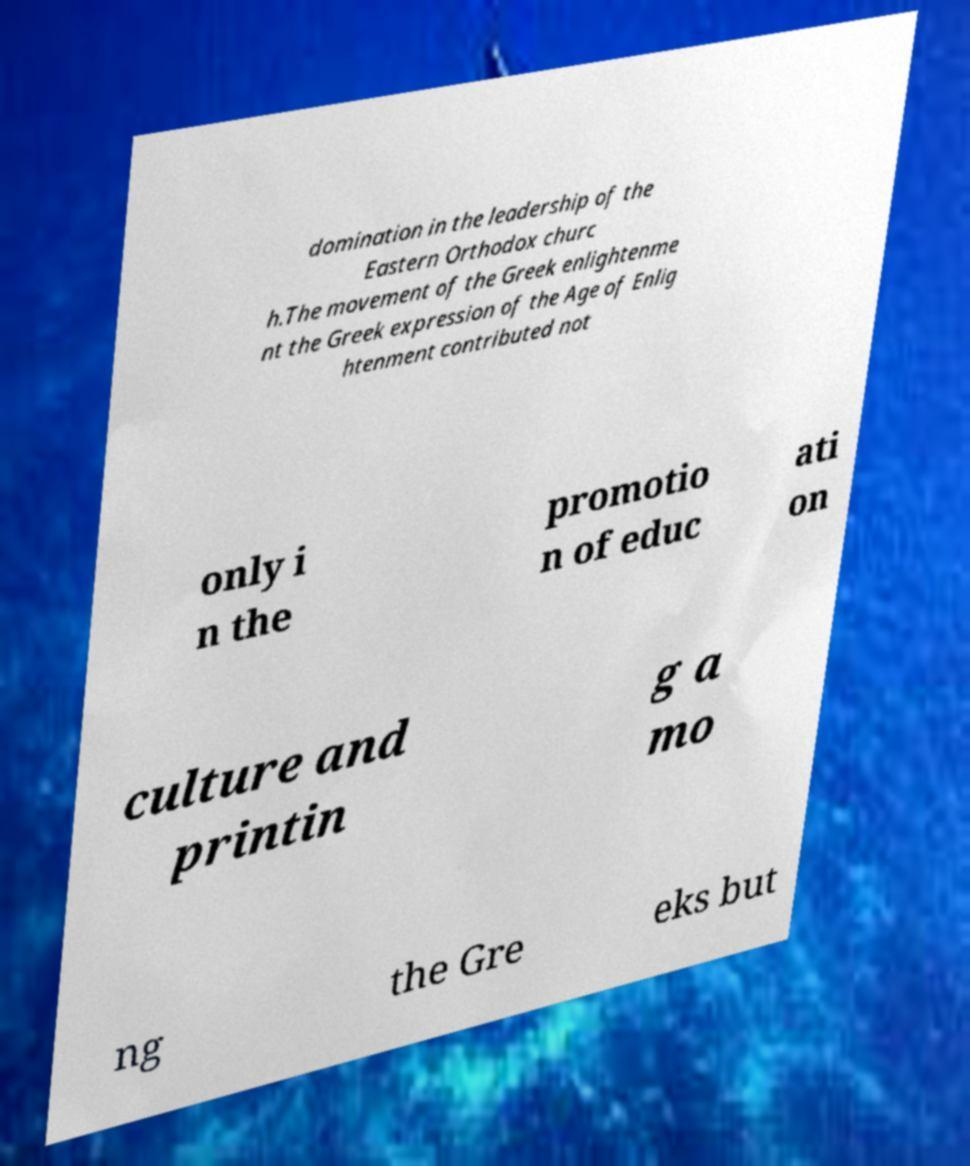Could you assist in decoding the text presented in this image and type it out clearly? domination in the leadership of the Eastern Orthodox churc h.The movement of the Greek enlightenme nt the Greek expression of the Age of Enlig htenment contributed not only i n the promotio n of educ ati on culture and printin g a mo ng the Gre eks but 